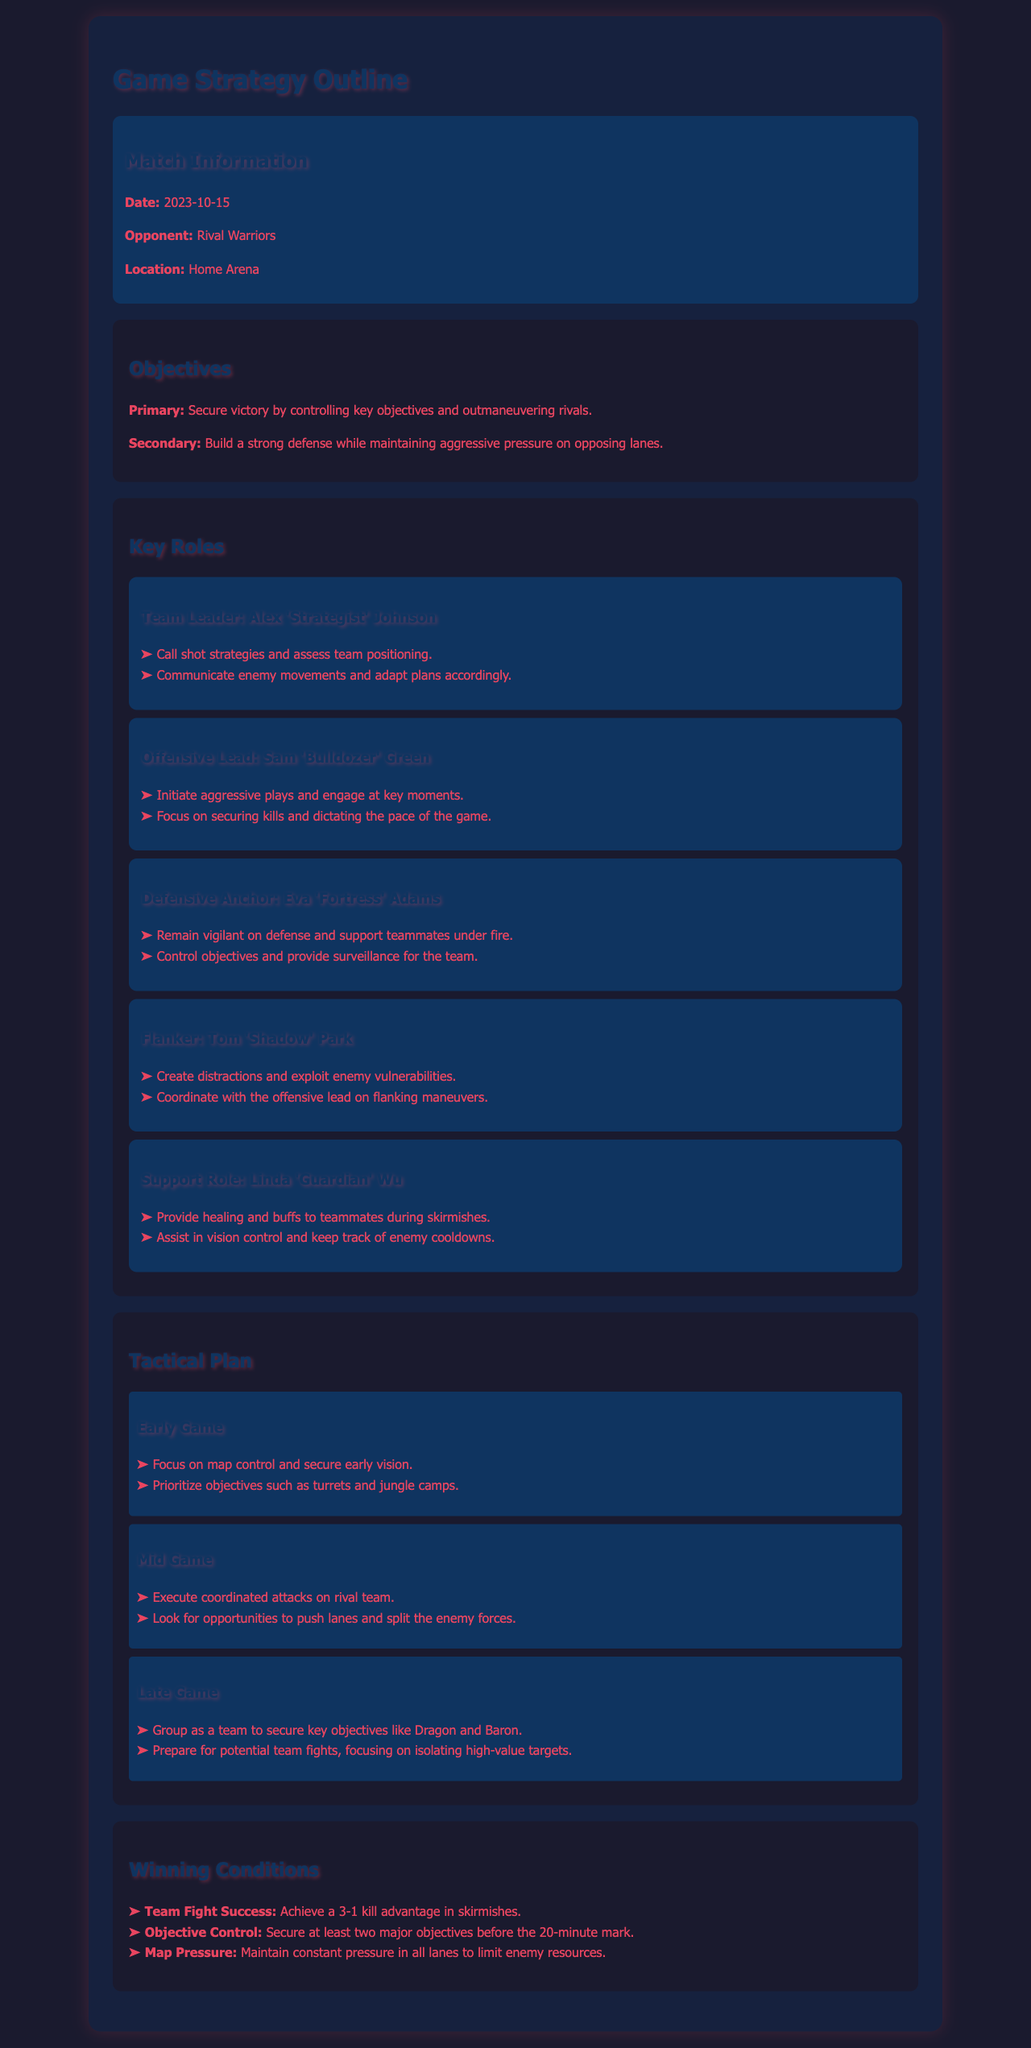what is the match date? The match date is listed in the match information section of the document.
Answer: 2023-10-15 who is the Offensive Lead? The Offensive Lead is mentioned in the key roles section.
Answer: Sam 'Bulldozer' Green what is the primary objective of the match? The primary objective is stated clearly under the objectives section.
Answer: Secure victory by controlling key objectives and outmaneuvering rivals how many major objectives should be secured by the 20-minute mark? This information is specified in the winning conditions section of the document.
Answer: At least two what is the main focus during the Late Game phase? The main focus for the Late Game is detailed in the tactical plan under late game strategies.
Answer: Group as a team to secure key objectives like Dragon and Baron who is responsible for providing healing and buffs? This role is identified in the key roles section of the document.
Answer: Linda 'Guardian' Wu what should be prioritized in the Early Game? The primary focus is mentioned in the tactical plan for the early game.
Answer: Map control and secure early vision what should be achieved in team fights according to the winning conditions? This condition is specified in the winning conditions section.
Answer: A 3-1 kill advantage in skirmishes 